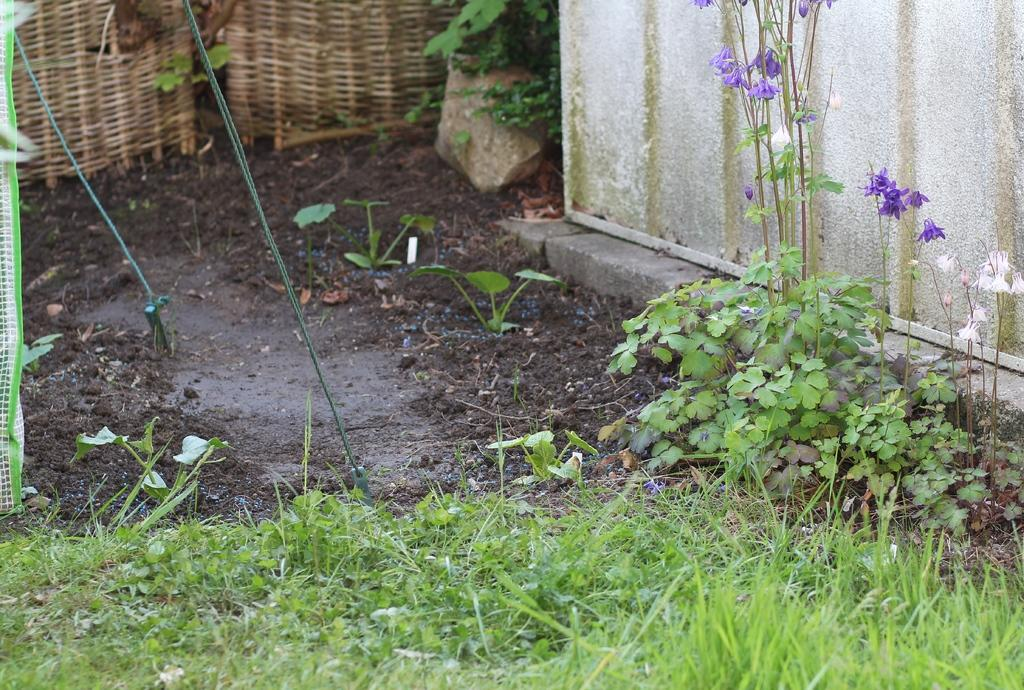What type of plants are present in the image? There are plants with flowers in the image. Can you describe the ground in the image? The ground in the image is covered with grass. What other object can be seen in the image? There is a stone visible in the image. How many wings can be seen on the flowers in the image? Flowers do not have wings, so there are no wings visible on the flowers in the image. 